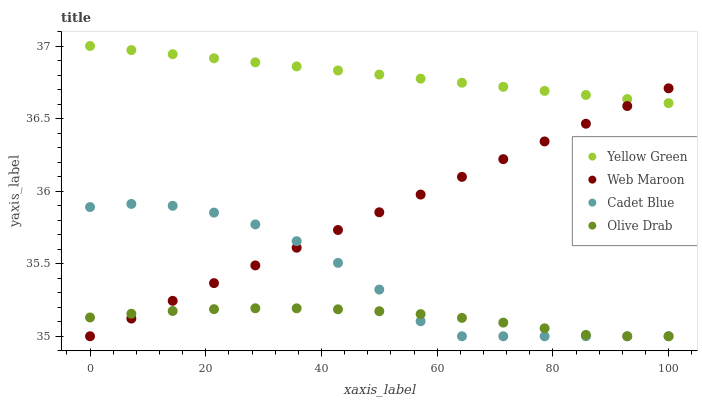Does Olive Drab have the minimum area under the curve?
Answer yes or no. Yes. Does Yellow Green have the maximum area under the curve?
Answer yes or no. Yes. Does Web Maroon have the minimum area under the curve?
Answer yes or no. No. Does Web Maroon have the maximum area under the curve?
Answer yes or no. No. Is Web Maroon the smoothest?
Answer yes or no. Yes. Is Cadet Blue the roughest?
Answer yes or no. Yes. Is Yellow Green the smoothest?
Answer yes or no. No. Is Yellow Green the roughest?
Answer yes or no. No. Does Cadet Blue have the lowest value?
Answer yes or no. Yes. Does Yellow Green have the lowest value?
Answer yes or no. No. Does Yellow Green have the highest value?
Answer yes or no. Yes. Does Web Maroon have the highest value?
Answer yes or no. No. Is Cadet Blue less than Yellow Green?
Answer yes or no. Yes. Is Yellow Green greater than Cadet Blue?
Answer yes or no. Yes. Does Web Maroon intersect Cadet Blue?
Answer yes or no. Yes. Is Web Maroon less than Cadet Blue?
Answer yes or no. No. Is Web Maroon greater than Cadet Blue?
Answer yes or no. No. Does Cadet Blue intersect Yellow Green?
Answer yes or no. No. 